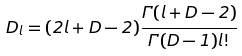Convert formula to latex. <formula><loc_0><loc_0><loc_500><loc_500>D _ { l } = ( 2 l + D - 2 ) \frac { \Gamma ( l + D - 2 ) } { \Gamma ( D - 1 ) l ! }</formula> 